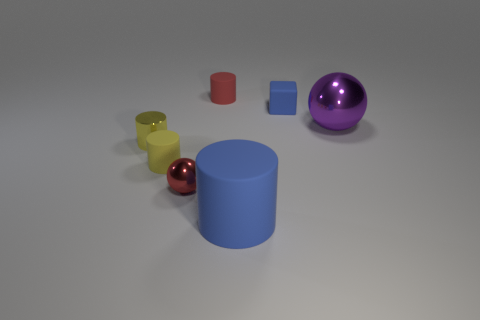Can you tell me about the materials of the objects shown in the image? Certainly! The objects in the image consist of what appears to be materials with different properties and finishes. The yellow and the large blue cylinders have a metallic luster, suggesting they are made of metal. The red and small blue objects have a matte finish, indicative of a plastic or rubber material. The purple and the small red spheres have a glossy finish, which could suggest a glass or polished metal composition. 